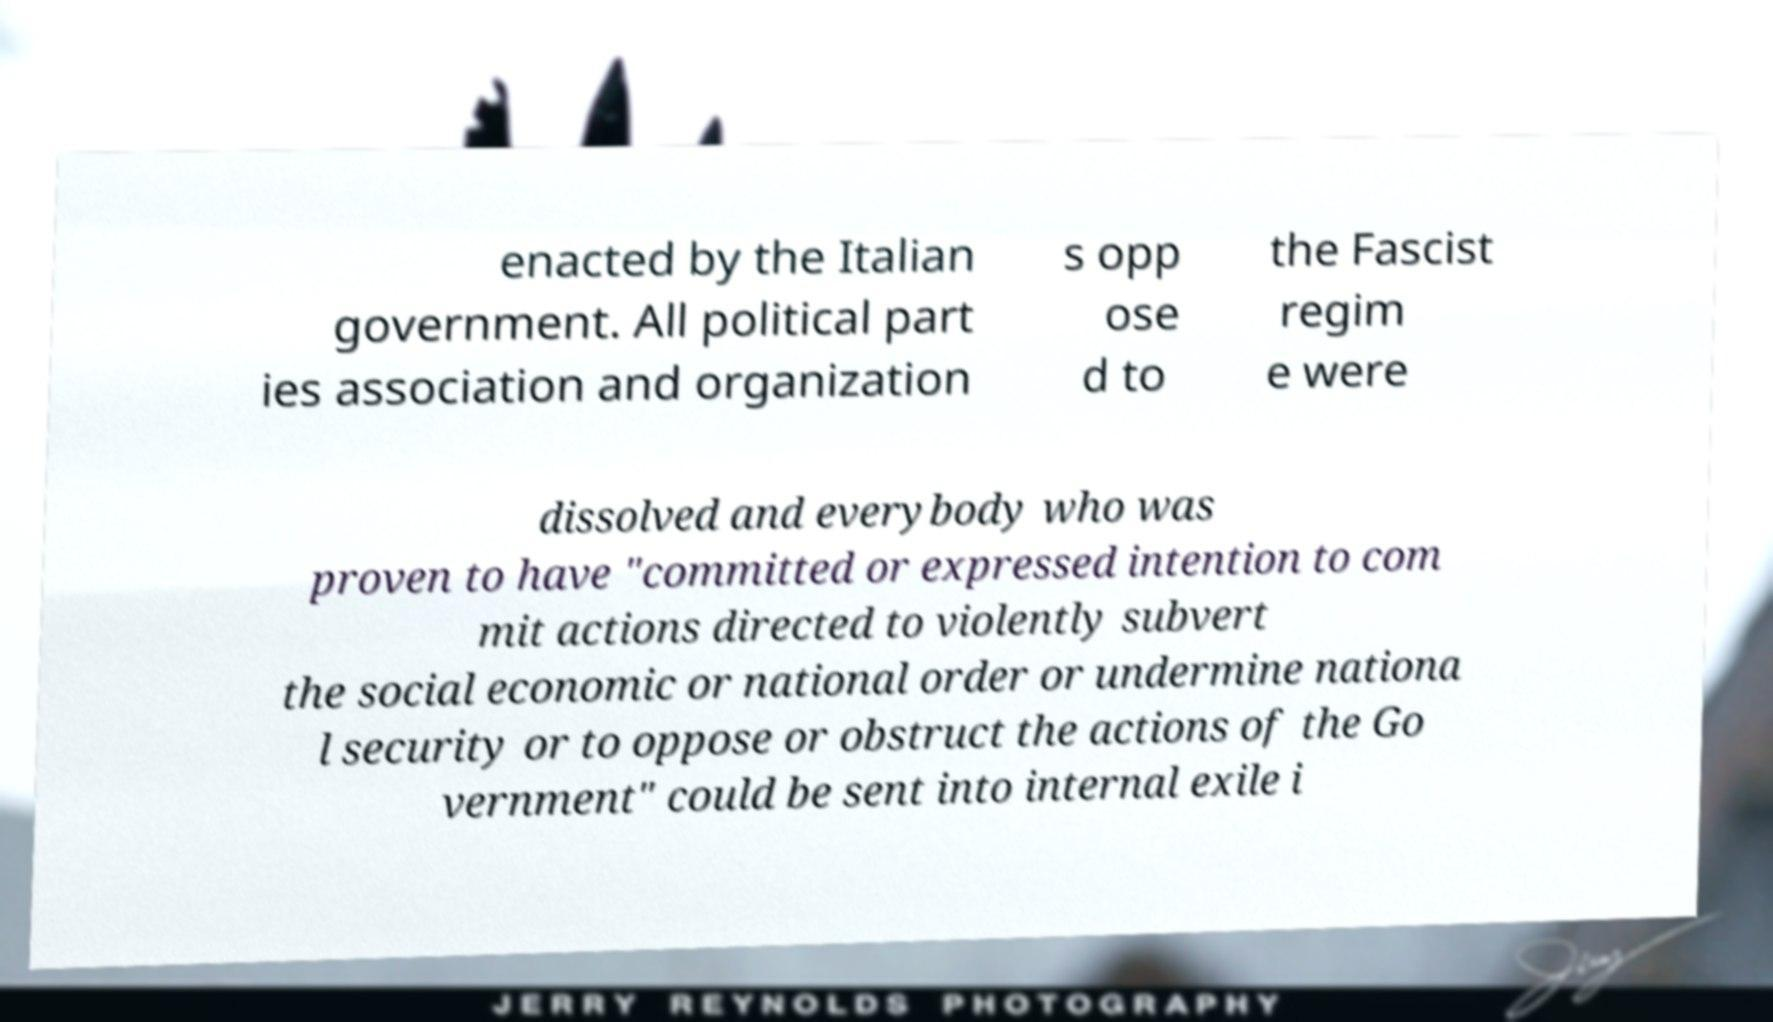Can you accurately transcribe the text from the provided image for me? enacted by the Italian government. All political part ies association and organization s opp ose d to the Fascist regim e were dissolved and everybody who was proven to have "committed or expressed intention to com mit actions directed to violently subvert the social economic or national order or undermine nationa l security or to oppose or obstruct the actions of the Go vernment" could be sent into internal exile i 